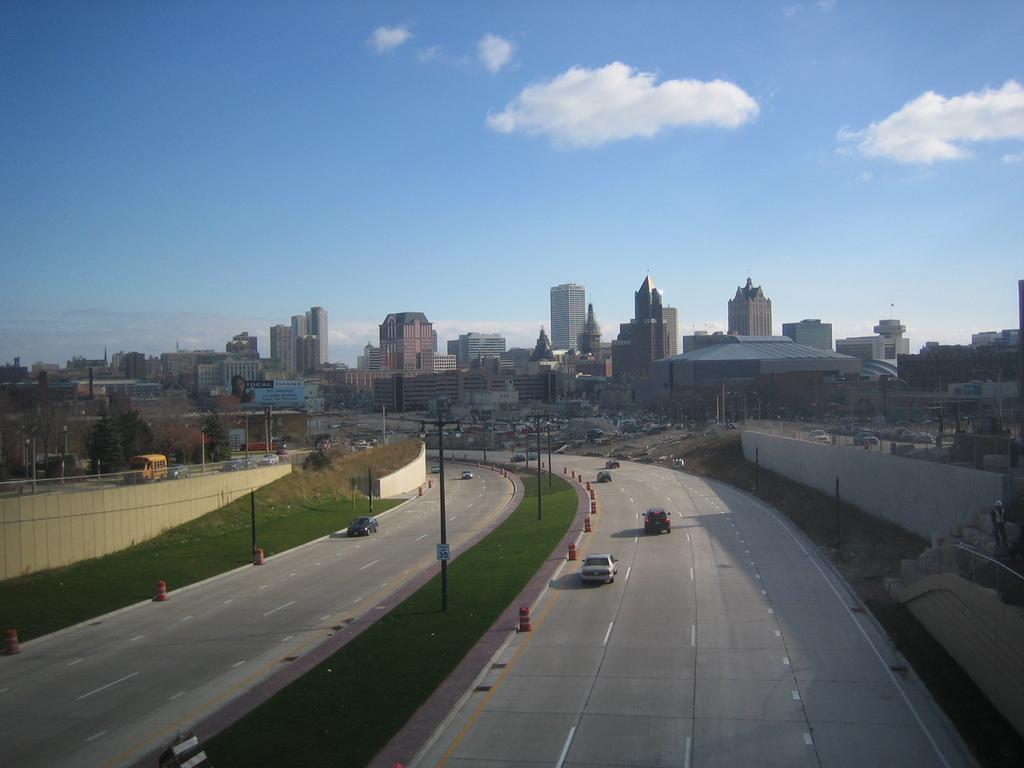Describe this image in one or two sentences. This is an aerial view image of a place which consists of roads, street lights, vehicles, buildings and lights. 